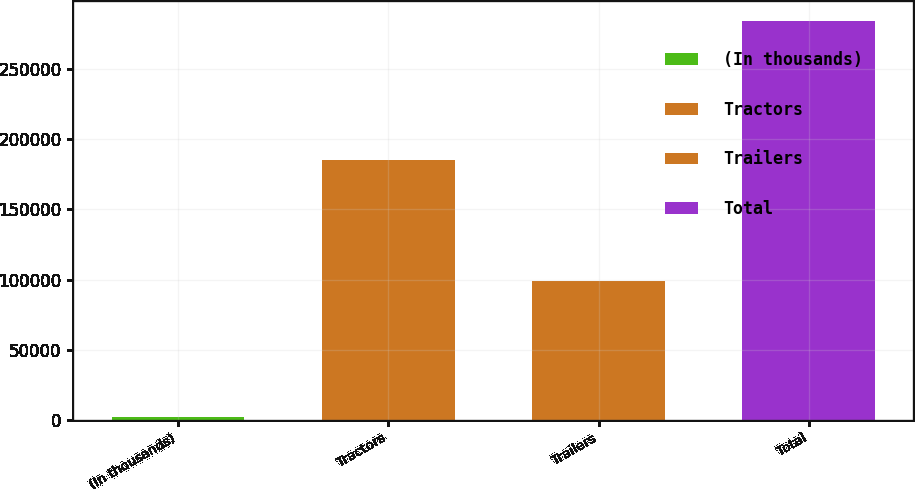Convert chart. <chart><loc_0><loc_0><loc_500><loc_500><bar_chart><fcel>(In thousands)<fcel>Tractors<fcel>Trailers<fcel>Total<nl><fcel>2018<fcel>185209<fcel>98835<fcel>284044<nl></chart> 